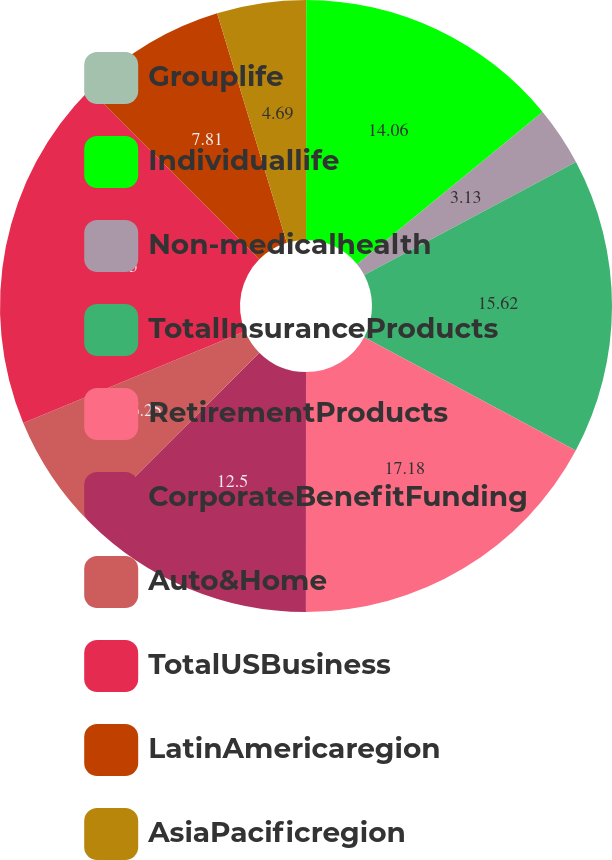<chart> <loc_0><loc_0><loc_500><loc_500><pie_chart><fcel>Grouplife<fcel>Individuallife<fcel>Non-medicalhealth<fcel>TotalInsuranceProducts<fcel>RetirementProducts<fcel>CorporateBenefitFunding<fcel>Auto&Home<fcel>TotalUSBusiness<fcel>LatinAmericaregion<fcel>AsiaPacificregion<nl><fcel>0.01%<fcel>14.06%<fcel>3.13%<fcel>15.62%<fcel>17.18%<fcel>12.5%<fcel>6.25%<fcel>18.74%<fcel>7.81%<fcel>4.69%<nl></chart> 